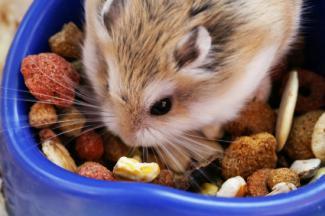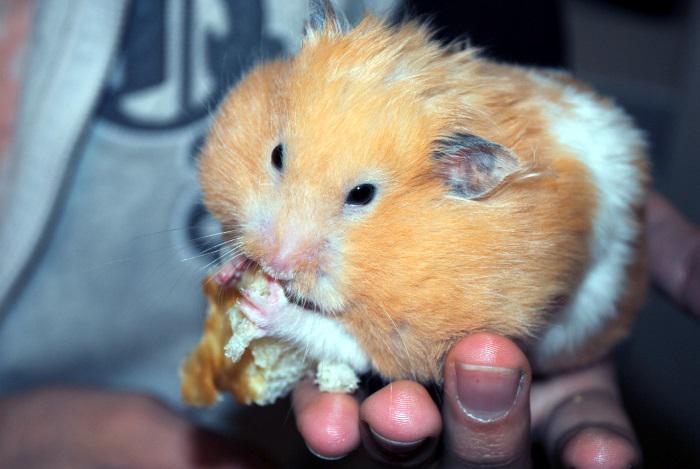The first image is the image on the left, the second image is the image on the right. For the images displayed, is the sentence "Each image shows one hamster with food in front of it, and the right image features a hamster with a peach-colored face clutching a piece of food to its face." factually correct? Answer yes or no. Yes. The first image is the image on the left, the second image is the image on the right. Considering the images on both sides, is "Two hamsters are eating." valid? Answer yes or no. Yes. 